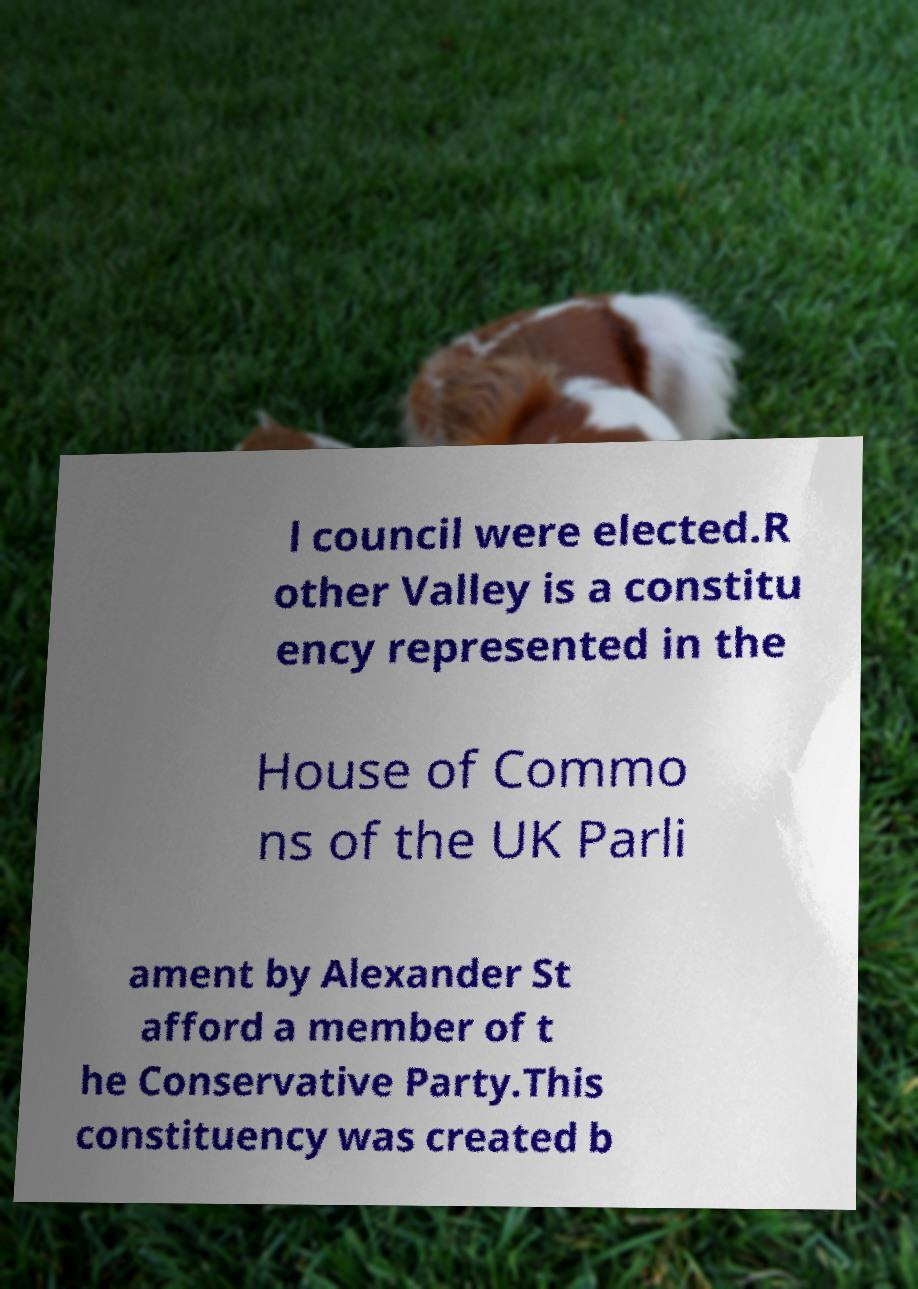Can you read and provide the text displayed in the image?This photo seems to have some interesting text. Can you extract and type it out for me? l council were elected.R other Valley is a constitu ency represented in the House of Commo ns of the UK Parli ament by Alexander St afford a member of t he Conservative Party.This constituency was created b 